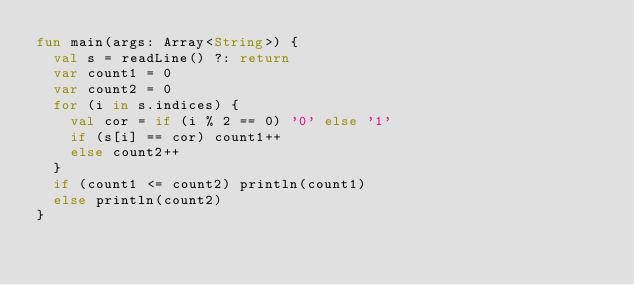<code> <loc_0><loc_0><loc_500><loc_500><_Kotlin_>fun main(args: Array<String>) {
	val s = readLine() ?: return
	var count1 = 0
	var count2 = 0
	for (i in s.indices) {
		val cor = if (i % 2 == 0) '0' else '1'
		if (s[i] == cor) count1++
		else count2++
	}
	if (count1 <= count2) println(count1)
	else println(count2)
}</code> 